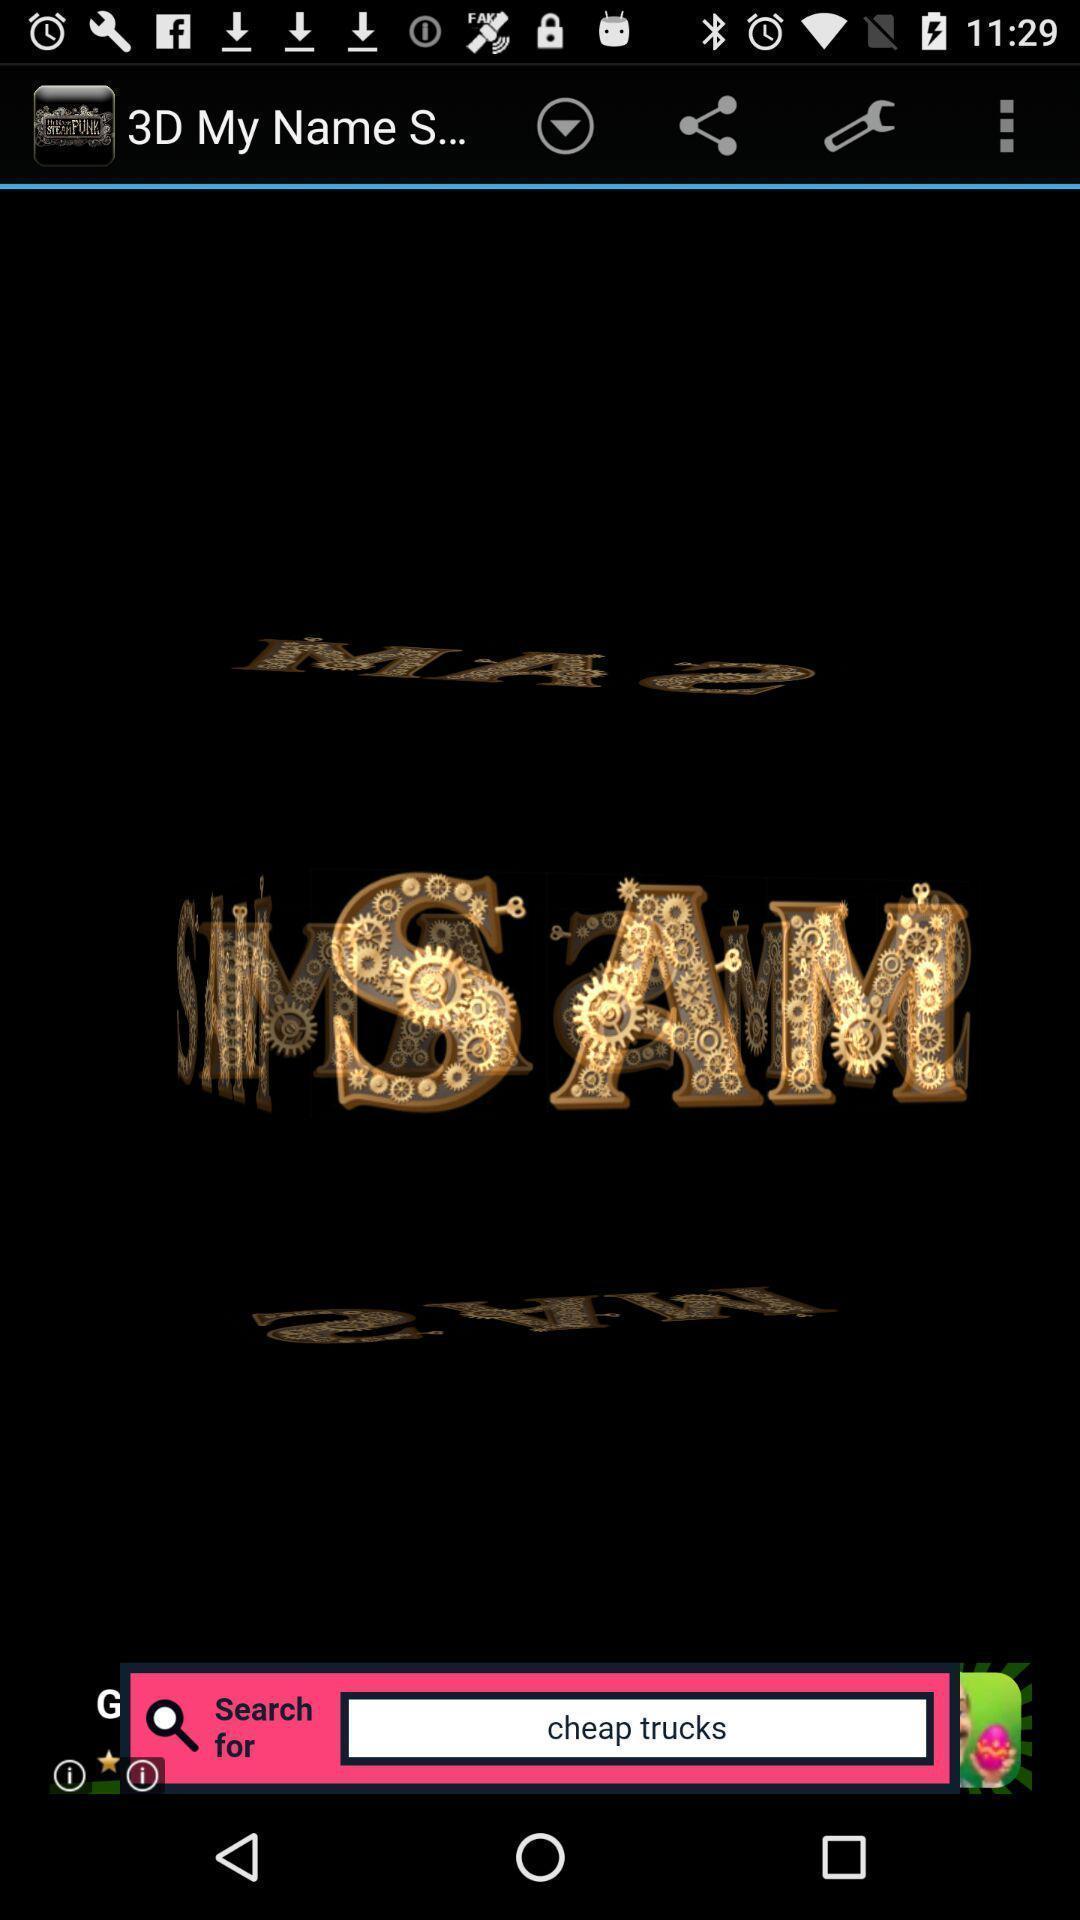Summarize the information in this screenshot. Page shows search bar and some text. 